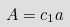Convert formula to latex. <formula><loc_0><loc_0><loc_500><loc_500>A = c _ { 1 } a</formula> 